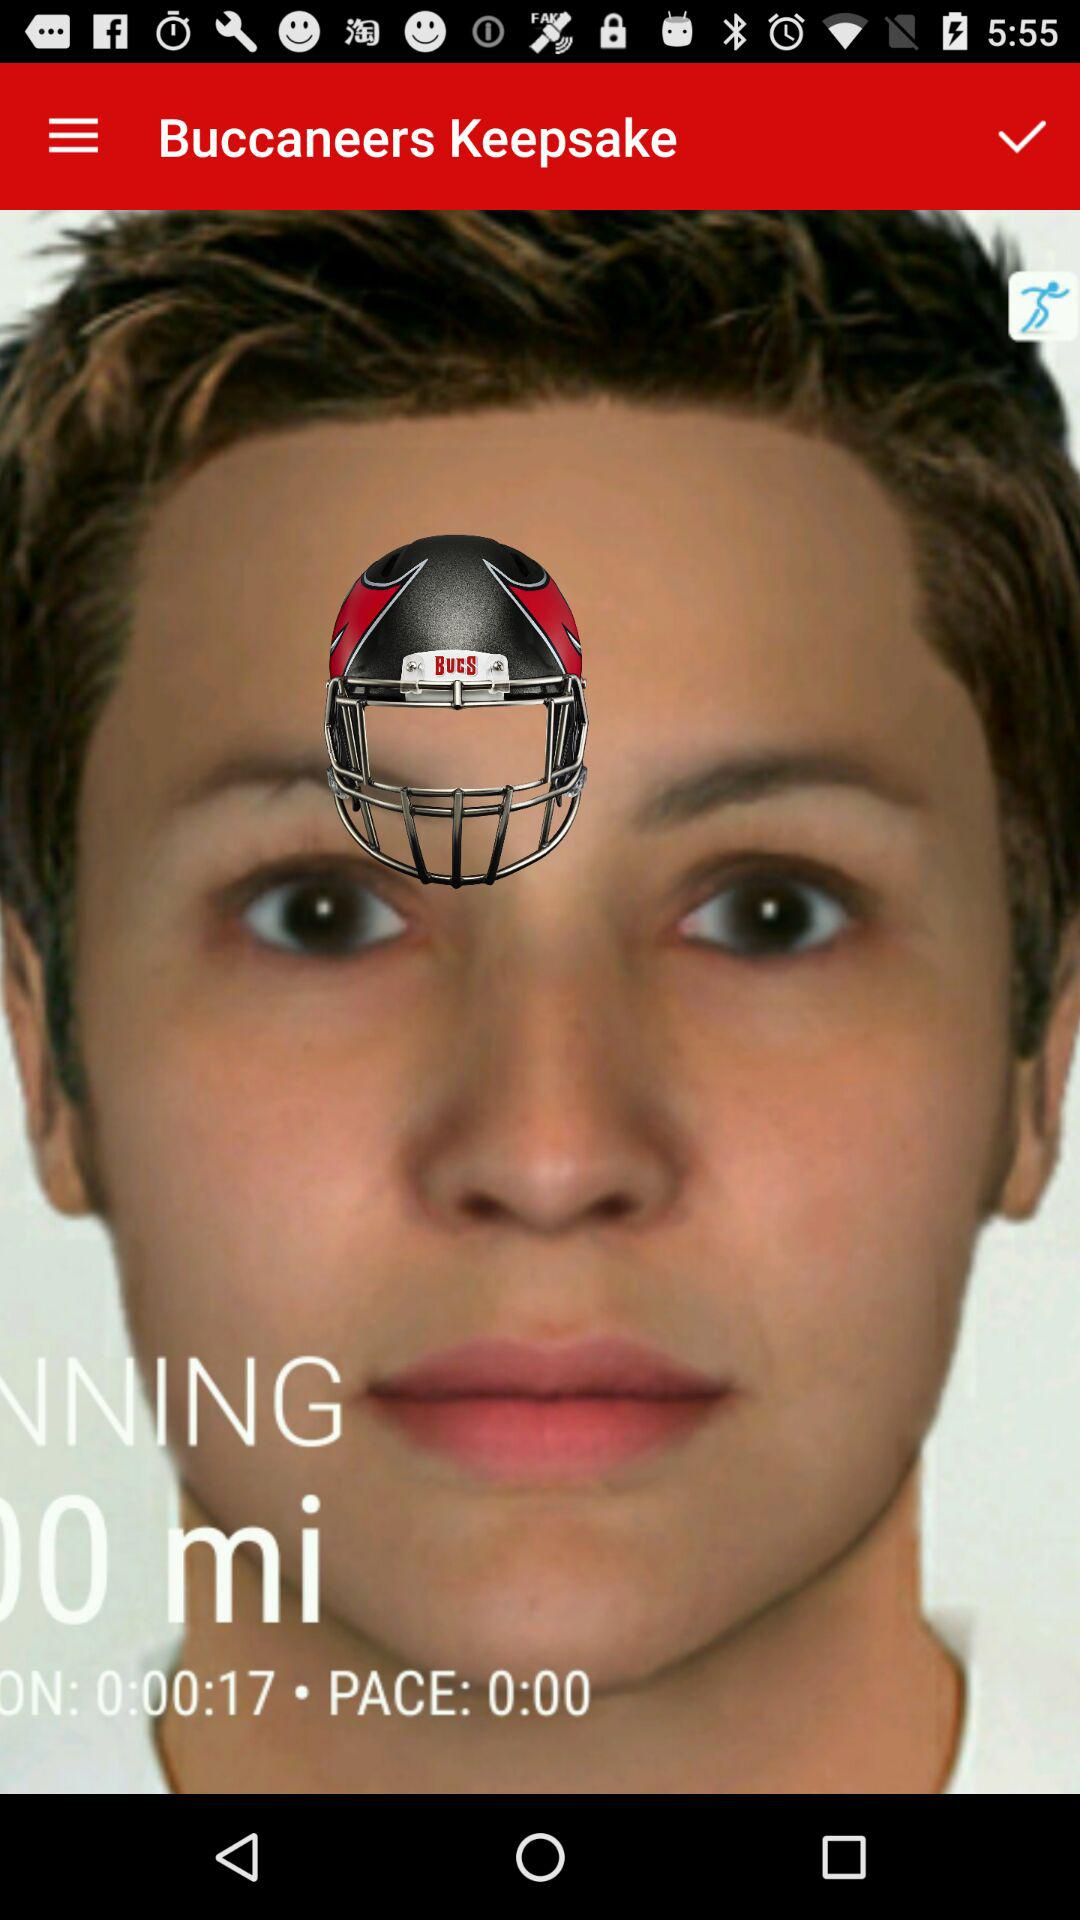How many more seconds are left on the timer than miles have been run?
Answer the question using a single word or phrase. 17 